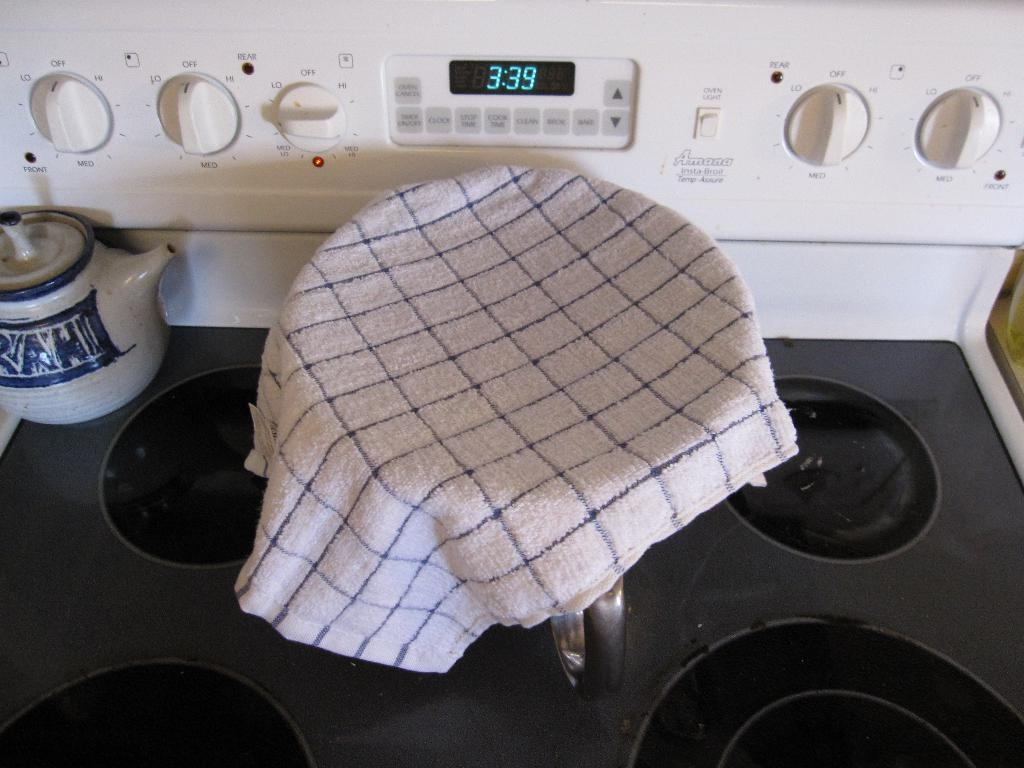<image>
Share a concise interpretation of the image provided. The blue-light digital clock indicates the time is 3:39. 